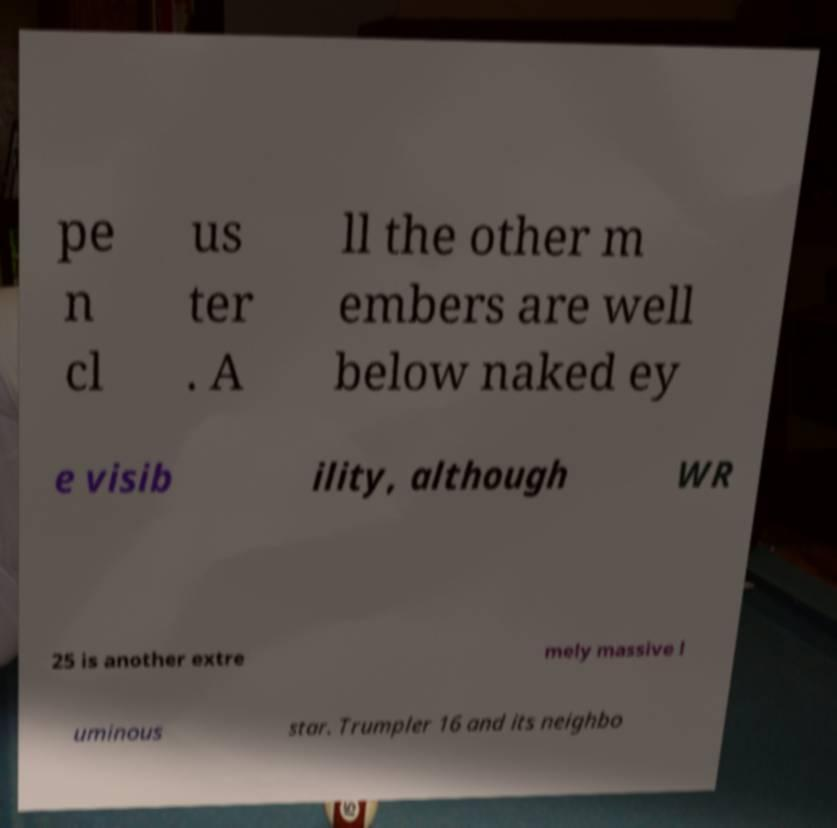Could you assist in decoding the text presented in this image and type it out clearly? pe n cl us ter . A ll the other m embers are well below naked ey e visib ility, although WR 25 is another extre mely massive l uminous star. Trumpler 16 and its neighbo 